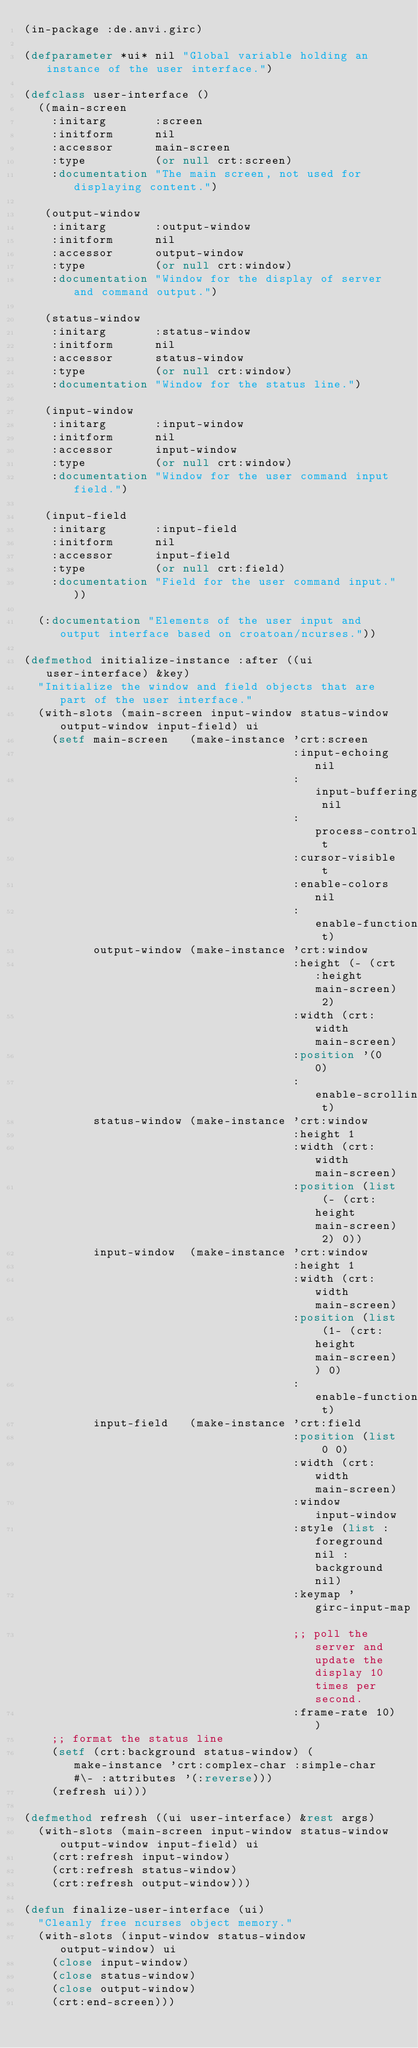Convert code to text. <code><loc_0><loc_0><loc_500><loc_500><_Lisp_>(in-package :de.anvi.girc)

(defparameter *ui* nil "Global variable holding an instance of the user interface.")

(defclass user-interface ()
  ((main-screen
    :initarg       :screen
    :initform      nil
    :accessor      main-screen
    :type          (or null crt:screen)
    :documentation "The main screen, not used for displaying content.")

   (output-window
    :initarg       :output-window
    :initform      nil
    :accessor      output-window
    :type          (or null crt:window)
    :documentation "Window for the display of server and command output.")

   (status-window
    :initarg       :status-window
    :initform      nil
    :accessor      status-window
    :type          (or null crt:window)
    :documentation "Window for the status line.")

   (input-window
    :initarg       :input-window
    :initform      nil
    :accessor      input-window
    :type          (or null crt:window)
    :documentation "Window for the user command input field.")

   (input-field
    :initarg       :input-field
    :initform      nil
    :accessor      input-field
    :type          (or null crt:field)
    :documentation "Field for the user command input."))

  (:documentation "Elements of the user input and output interface based on croatoan/ncurses."))

(defmethod initialize-instance :after ((ui user-interface) &key)
  "Initialize the window and field objects that are part of the user interface."
  (with-slots (main-screen input-window status-window output-window input-field) ui
    (setf main-screen   (make-instance 'crt:screen
                                       :input-echoing nil
                                       :input-buffering nil
                                       :process-control-chars t
                                       :cursor-visible t
                                       :enable-colors nil
                                       :enable-function-keys t)
          output-window (make-instance 'crt:window
                                       :height (- (crt:height main-screen) 2)
                                       :width (crt:width main-screen)
                                       :position '(0 0)
                                       :enable-scrolling t)
          status-window (make-instance 'crt:window
                                       :height 1
                                       :width (crt:width main-screen)
                                       :position (list (- (crt:height main-screen) 2) 0))
          input-window  (make-instance 'crt:window
                                       :height 1
                                       :width (crt:width main-screen)
                                       :position (list (1- (crt:height main-screen)) 0)
                                       :enable-function-keys t)
          input-field   (make-instance 'crt:field
                                       :position (list 0 0)
                                       :width (crt:width main-screen)
                                       :window input-window
                                       :style (list :foreground nil :background nil)
                                       :keymap 'girc-input-map
                                       ;; poll the server and update the display 10 times per second.
                                       :frame-rate 10))
    ;; format the status line
    (setf (crt:background status-window) (make-instance 'crt:complex-char :simple-char #\- :attributes '(:reverse)))
    (refresh ui)))

(defmethod refresh ((ui user-interface) &rest args)
  (with-slots (main-screen input-window status-window output-window input-field) ui
    (crt:refresh input-window)
    (crt:refresh status-window)
    (crt:refresh output-window)))

(defun finalize-user-interface (ui)
  "Cleanly free ncurses object memory."
  (with-slots (input-window status-window output-window) ui
    (close input-window)
    (close status-window)
    (close output-window)
    (crt:end-screen)))
</code> 